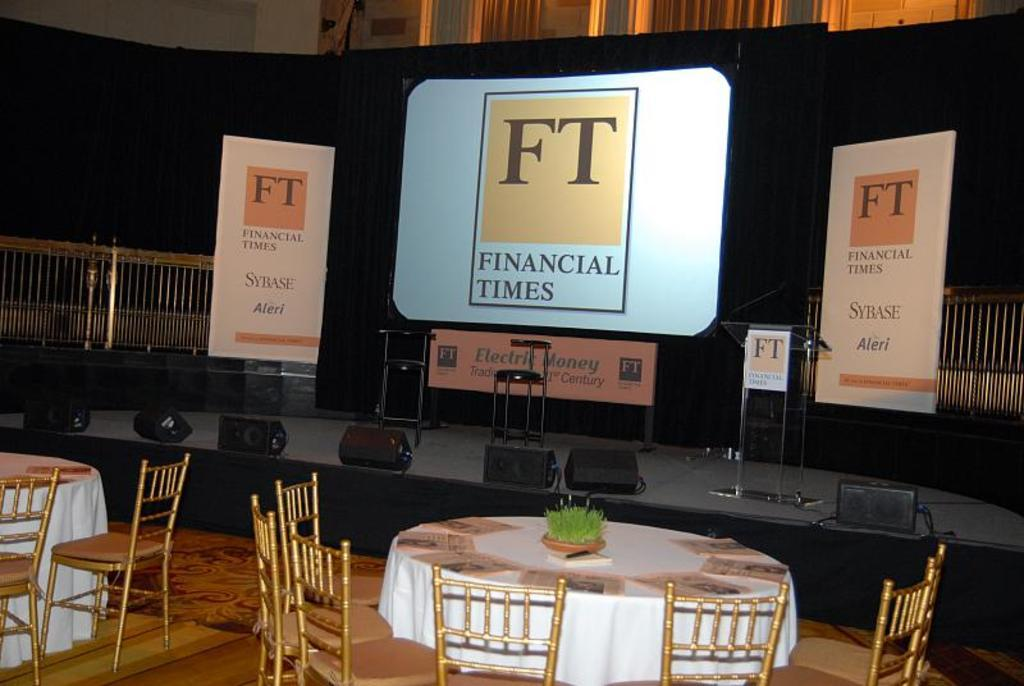<image>
Create a compact narrative representing the image presented. A stage with Financial Times posters decorating it sits empty in front of equally empty tables and chairs. 